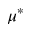<formula> <loc_0><loc_0><loc_500><loc_500>\mu ^ { * }</formula> 